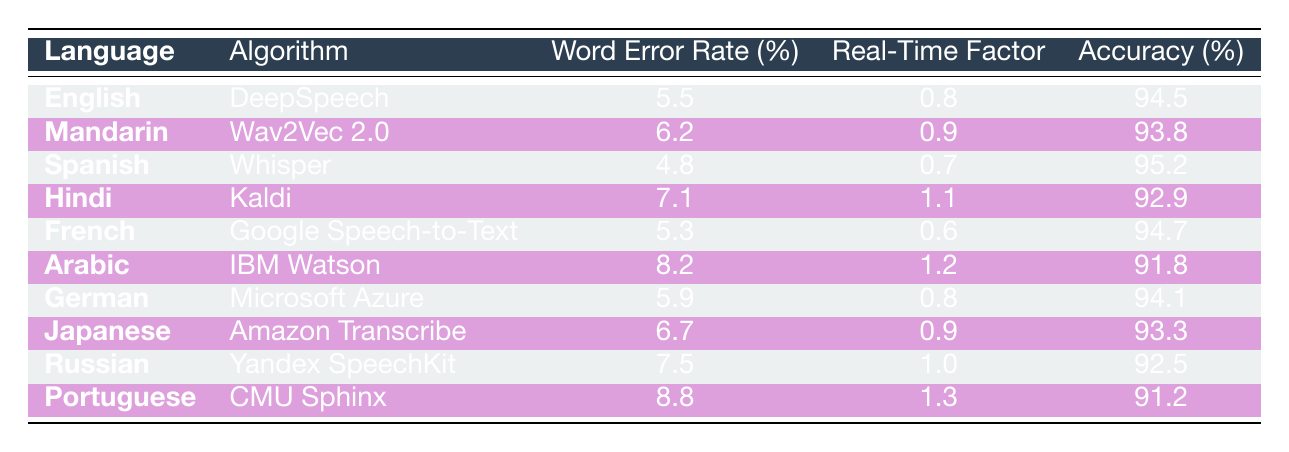What is the Word Error Rate for Spanish using the Whisper algorithm? The table shows that the Word Error Rate for Spanish with the Whisper algorithm is listed in the corresponding row under the "Word Error Rate (%)" column, which is 4.8.
Answer: 4.8 Which language has the highest accuracy rate and what is that value? By examining the accuracy rates in the table, Spanish has the highest value of 95.2%, which is located in the row for the Whisper algorithm.
Answer: 95.2 Is the Real-Time Factor for Arabic greater than that for French? The Real-Time Factor for Arabic (1.2) is compared to that for French (0.6) by looking at the respective rows. Since 1.2 is greater than 0.6, the statement is true.
Answer: Yes What is the average Word Error Rate for the German and English algorithms? To calculate the average, add the Word Error Rates for German (5.9) and English (5.5) together, which equals 11.4. Dividing by 2 gives an average of 5.7.
Answer: 5.7 How many algorithms have a Word Error Rate less than 6%? By reviewing the table, the algorithms with a Word Error Rate below 6% are English (5.5), Spanish (4.8), and French (5.3), totaling three algorithms.
Answer: 3 Which algorithm has the lowest Real-Time Factor? The Real-Time Factors are compared across algorithms, and the lowest value is found in the row for French with a value of 0.6.
Answer: 0.6 Is the accuracy for Portuguese using CMU Sphinx above 92%? The accuracy for Portuguese is listed as 91.2%. Since 91.2% is not above 92%, the statement is false.
Answer: No What is the difference in Word Error Rate between the best and the worst performing algorithms? The best Word Error Rate is for Spanish with 4.8% and the worst is for Portuguese at 8.8%. The difference is calculated as 8.8 - 4.8 = 4.0.
Answer: 4.0 Which language has a higher Real-Time Factor, Hindi or Japanese? The Real-Time Factor for Hindi is 1.1 and for Japanese, it is 0.9. Since 1.1 is greater than 0.9, Hindi has a higher Real-Time Factor.
Answer: Hindi 